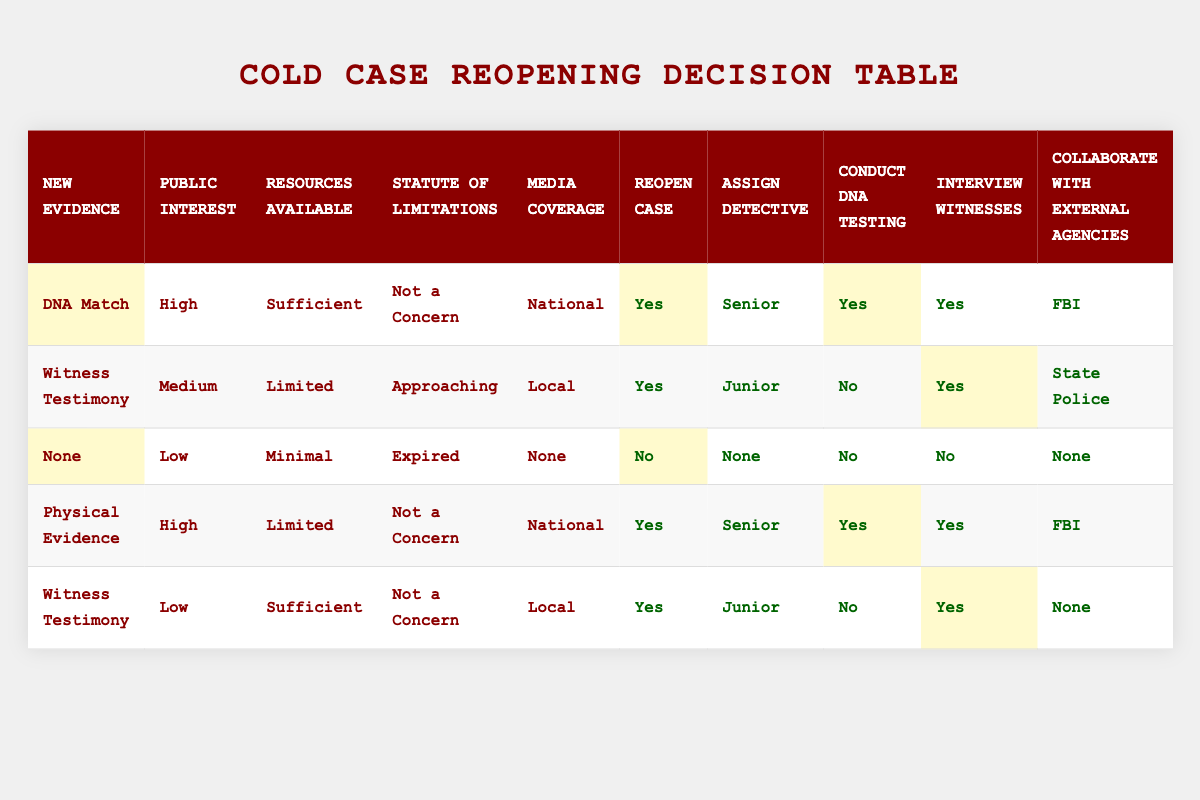What is the action taken when there is a DNA match with high public interest and sufficient resources? The table indicates that under these conditions: "New Evidence" is DNA Match, "Public Interest" is High, and "Resources Available" is Sufficient, the action "Reopen Case" is designated as Yes, and "Assign Detective" is Senior, among other actions.
Answer: Yes How many cases are reopened when there is no new evidence, low public interest, and minimal resources? According to the table, the conditions of "New Evidence" as None, "Public Interest" as Low, and "Resources Available" as Minimal lead to the action "Reopen Case" being marked as No.
Answer: No What detective level is assigned when reopening a case with witness testimony, medium public interest, limited resources, and an approaching statute of limitations? The table shows that the conditions are: "New Evidence" is Witness Testimony, "Public Interest" is Medium, "Resources Available" is Limited, and "Statute of Limitations" is Approaching. In this case, the assigned detective is a Junior.
Answer: Junior Are cases with physical evidence and high public interest always reopened? In examining the specific condition where "New Evidence" is Physical Evidence and "Public Interest" is High, the table indicates that the corresponding action is to "Reopen Case," affirmatively returning Yes for reopening the case.
Answer: Yes What are the actions taken in a case with no new evidence and a low level of public interest? The conditions indicating "New Evidence" as None, "Public Interest" as Low, "Resources Available" as Minimal, "Statute of Limitations" as Expired, and "Media Coverage" as None lead to all actions marked as No for reopening the case, conducting DNA testing, interviewing witnesses, and collaborating with external agencies.
Answer: All actions are No How many cases are assigned a senior detective when reopening occurs? By analyzing the table, both instances of reopening cases with high public interest and physical evidence involve assigning a Senior detective. Thus, there are two instances where a Senior detective is assigned.
Answer: 2 What is the average level of detective assigned across all reopening scenarios? The table lists detective assignments as Senior and Junior. Specifically, two cases employ a Senior detective and three cases employ a Junior. When calculating the average considering Senior = 1 and Junior = 0, we total 2 Senior and 3 Junior, giving an average level of (2*1 + 3*0)/(2 + 3) = 2/5, resulting in 0.4.
Answer: 0.4 If a case does not have media coverage but has high public interest and sufficient resources, what can be concluded regarding reopening? The table does not explicitly show these exact conditions. However, cases can be reopened with high public interest and sufficient resources based on the first rule involving DNA match without considering media coverage. Therefore, it can be inferred that it is possible to reopen the case under these circumstances.
Answer: Yes 